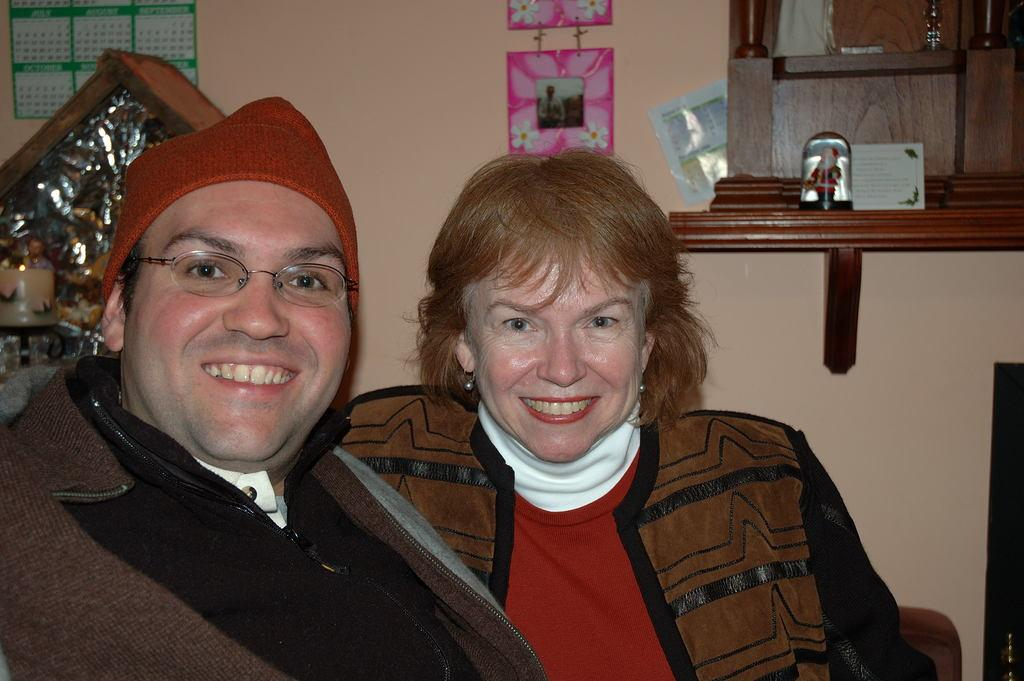What type of structure is present in the image? There is a wall in the image. What object is hanging on the wall in the image? There is a photo frame in the image. How many people are sitting in the image? There are two people sitting in the image. What type of hat is the giant wearing in the image? There are no giants or hats present in the image. 